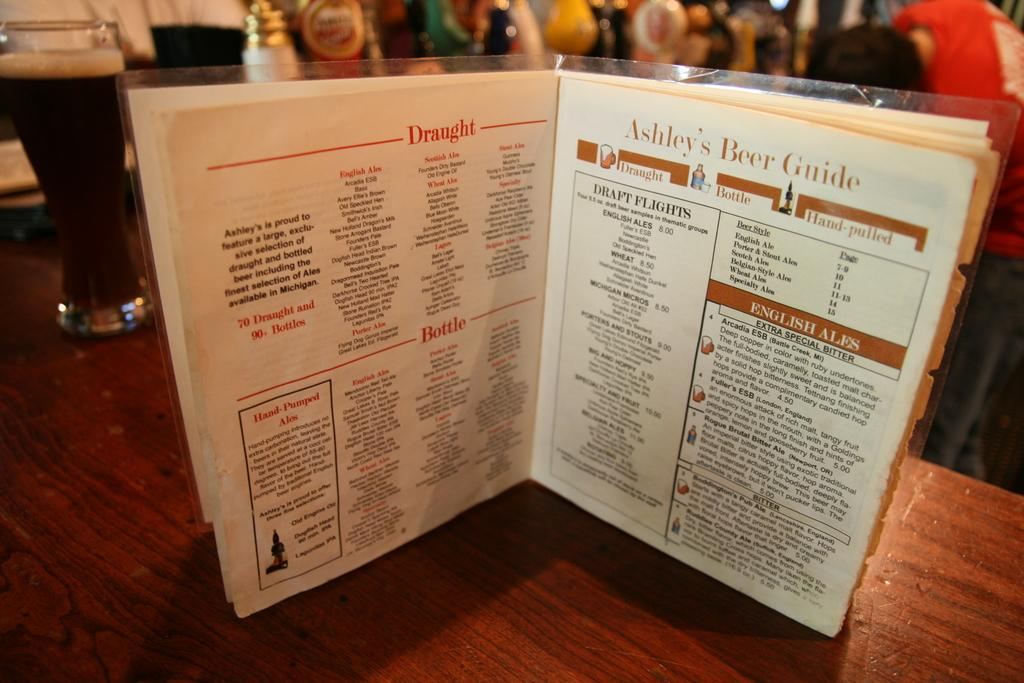<image>
Render a clear and concise summary of the photo. A menu containing Ashley's Beer Guide provides a choice of draught, bottle, or hand-pulled beer. 